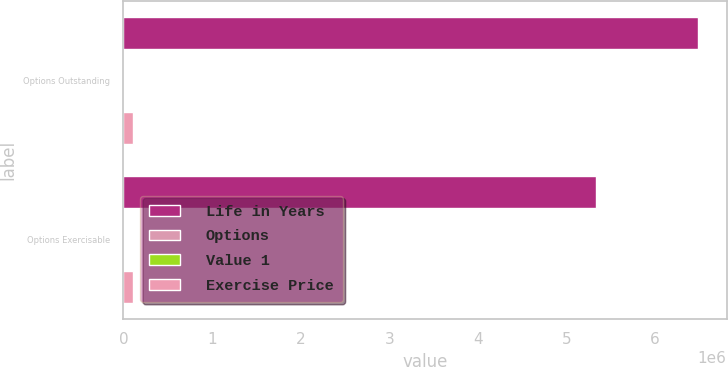Convert chart. <chart><loc_0><loc_0><loc_500><loc_500><stacked_bar_chart><ecel><fcel>Options Outstanding<fcel>Options Exercisable<nl><fcel>Life in Years<fcel>6.48383e+06<fcel>5.33604e+06<nl><fcel>Options<fcel>4.96<fcel>4.1<nl><fcel>Value 1<fcel>46.06<fcel>43.24<nl><fcel>Exercise Price<fcel>113379<fcel>110332<nl></chart> 